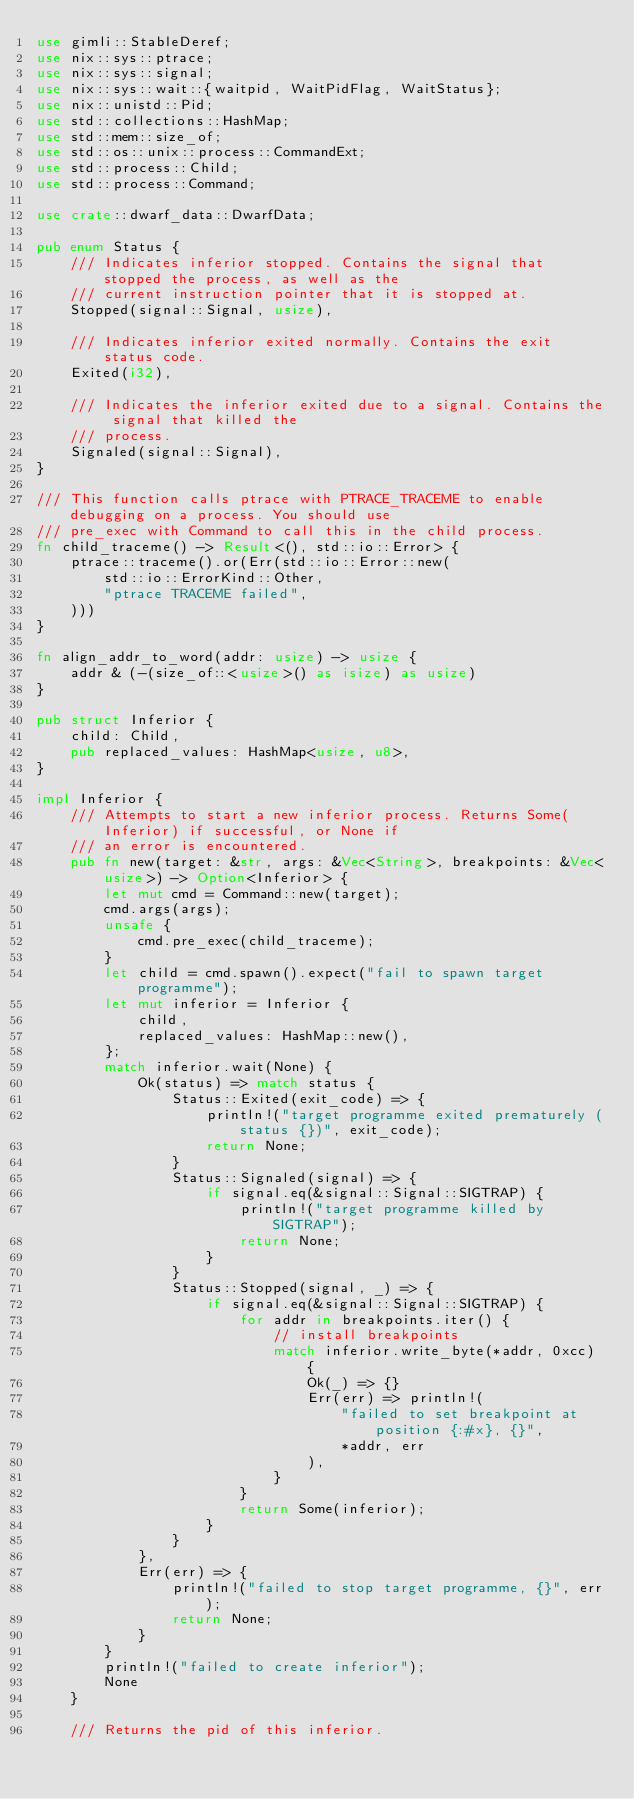Convert code to text. <code><loc_0><loc_0><loc_500><loc_500><_Rust_>use gimli::StableDeref;
use nix::sys::ptrace;
use nix::sys::signal;
use nix::sys::wait::{waitpid, WaitPidFlag, WaitStatus};
use nix::unistd::Pid;
use std::collections::HashMap;
use std::mem::size_of;
use std::os::unix::process::CommandExt;
use std::process::Child;
use std::process::Command;

use crate::dwarf_data::DwarfData;

pub enum Status {
    /// Indicates inferior stopped. Contains the signal that stopped the process, as well as the
    /// current instruction pointer that it is stopped at.
    Stopped(signal::Signal, usize),

    /// Indicates inferior exited normally. Contains the exit status code.
    Exited(i32),

    /// Indicates the inferior exited due to a signal. Contains the signal that killed the
    /// process.
    Signaled(signal::Signal),
}

/// This function calls ptrace with PTRACE_TRACEME to enable debugging on a process. You should use
/// pre_exec with Command to call this in the child process.
fn child_traceme() -> Result<(), std::io::Error> {
    ptrace::traceme().or(Err(std::io::Error::new(
        std::io::ErrorKind::Other,
        "ptrace TRACEME failed",
    )))
}

fn align_addr_to_word(addr: usize) -> usize {
    addr & (-(size_of::<usize>() as isize) as usize)
}

pub struct Inferior {
    child: Child,
    pub replaced_values: HashMap<usize, u8>,
}

impl Inferior {
    /// Attempts to start a new inferior process. Returns Some(Inferior) if successful, or None if
    /// an error is encountered.
    pub fn new(target: &str, args: &Vec<String>, breakpoints: &Vec<usize>) -> Option<Inferior> {
        let mut cmd = Command::new(target);
        cmd.args(args);
        unsafe {
            cmd.pre_exec(child_traceme);
        }
        let child = cmd.spawn().expect("fail to spawn target programme");
        let mut inferior = Inferior {
            child,
            replaced_values: HashMap::new(),
        };
        match inferior.wait(None) {
            Ok(status) => match status {
                Status::Exited(exit_code) => {
                    println!("target programme exited prematurely (status {})", exit_code);
                    return None;
                }
                Status::Signaled(signal) => {
                    if signal.eq(&signal::Signal::SIGTRAP) {
                        println!("target programme killed by SIGTRAP");
                        return None;
                    }
                }
                Status::Stopped(signal, _) => {
                    if signal.eq(&signal::Signal::SIGTRAP) {
                        for addr in breakpoints.iter() {
                            // install breakpoints
                            match inferior.write_byte(*addr, 0xcc) {
                                Ok(_) => {}
                                Err(err) => println!(
                                    "failed to set breakpoint at position {:#x}, {}",
                                    *addr, err
                                ),
                            }
                        }
                        return Some(inferior);
                    }
                }
            },
            Err(err) => {
                println!("failed to stop target programme, {}", err);
                return None;
            }
        }
        println!("failed to create inferior");
        None
    }

    /// Returns the pid of this inferior.</code> 